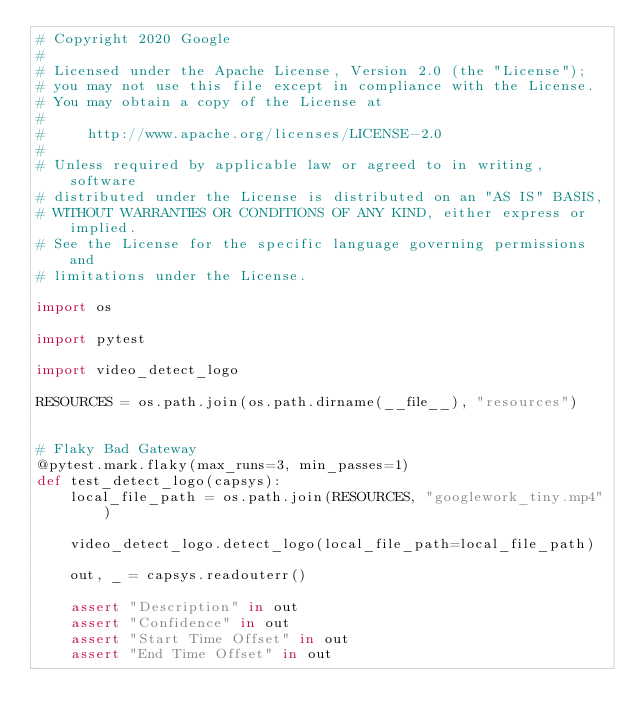Convert code to text. <code><loc_0><loc_0><loc_500><loc_500><_Python_># Copyright 2020 Google
#
# Licensed under the Apache License, Version 2.0 (the "License");
# you may not use this file except in compliance with the License.
# You may obtain a copy of the License at
#
#     http://www.apache.org/licenses/LICENSE-2.0
#
# Unless required by applicable law or agreed to in writing, software
# distributed under the License is distributed on an "AS IS" BASIS,
# WITHOUT WARRANTIES OR CONDITIONS OF ANY KIND, either express or implied.
# See the License for the specific language governing permissions and
# limitations under the License.

import os

import pytest

import video_detect_logo

RESOURCES = os.path.join(os.path.dirname(__file__), "resources")


# Flaky Bad Gateway
@pytest.mark.flaky(max_runs=3, min_passes=1)
def test_detect_logo(capsys):
    local_file_path = os.path.join(RESOURCES, "googlework_tiny.mp4")

    video_detect_logo.detect_logo(local_file_path=local_file_path)

    out, _ = capsys.readouterr()

    assert "Description" in out
    assert "Confidence" in out
    assert "Start Time Offset" in out
    assert "End Time Offset" in out
</code> 